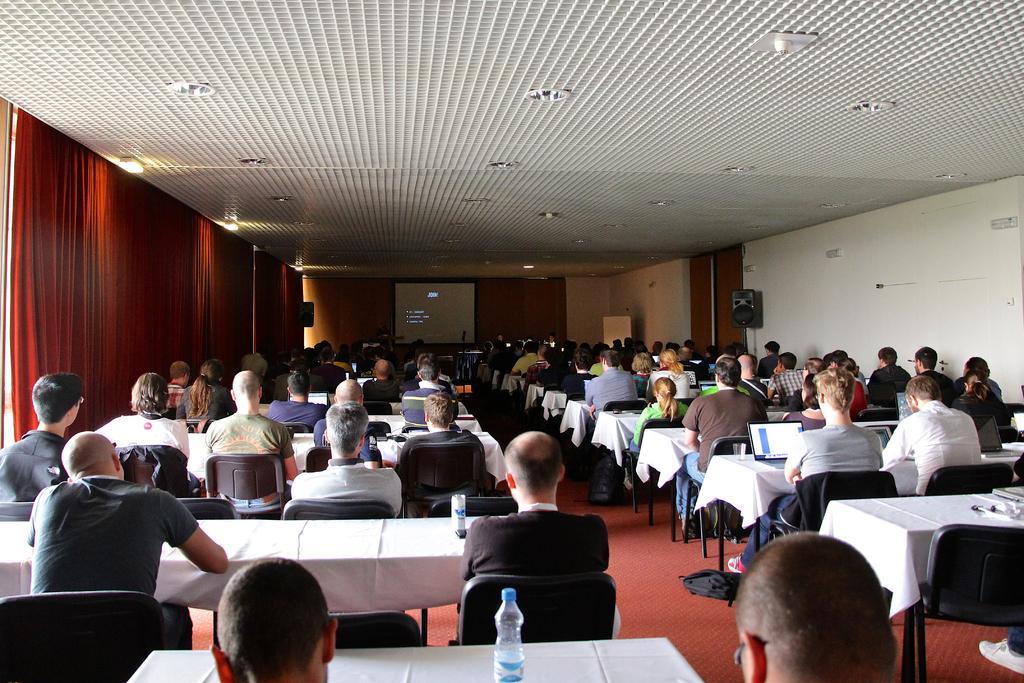Could you give a brief overview of what you see in this image? In the image there are sitting on chair in front of table looking at screen on the wall, this looks like a conference room. 